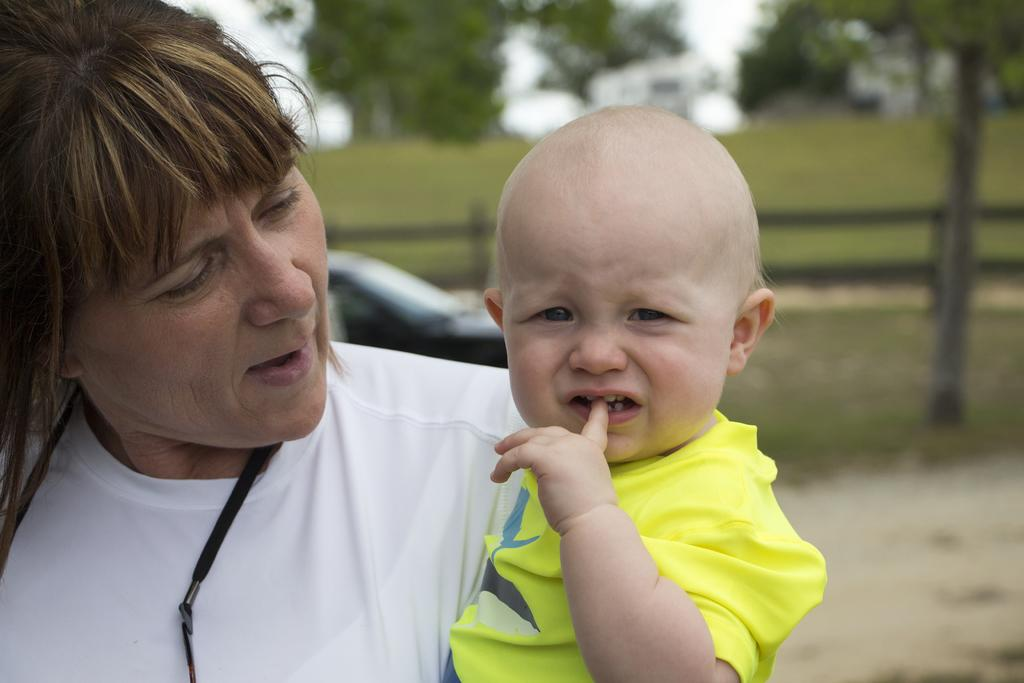Who is present in the image? There is a woman and a baby in the image. What can be seen in the background of the image? There is a car, fencing, trees, and grass in the background of the image. What language is the baby speaking in the image? The image does not provide any information about the language spoken by the baby. 